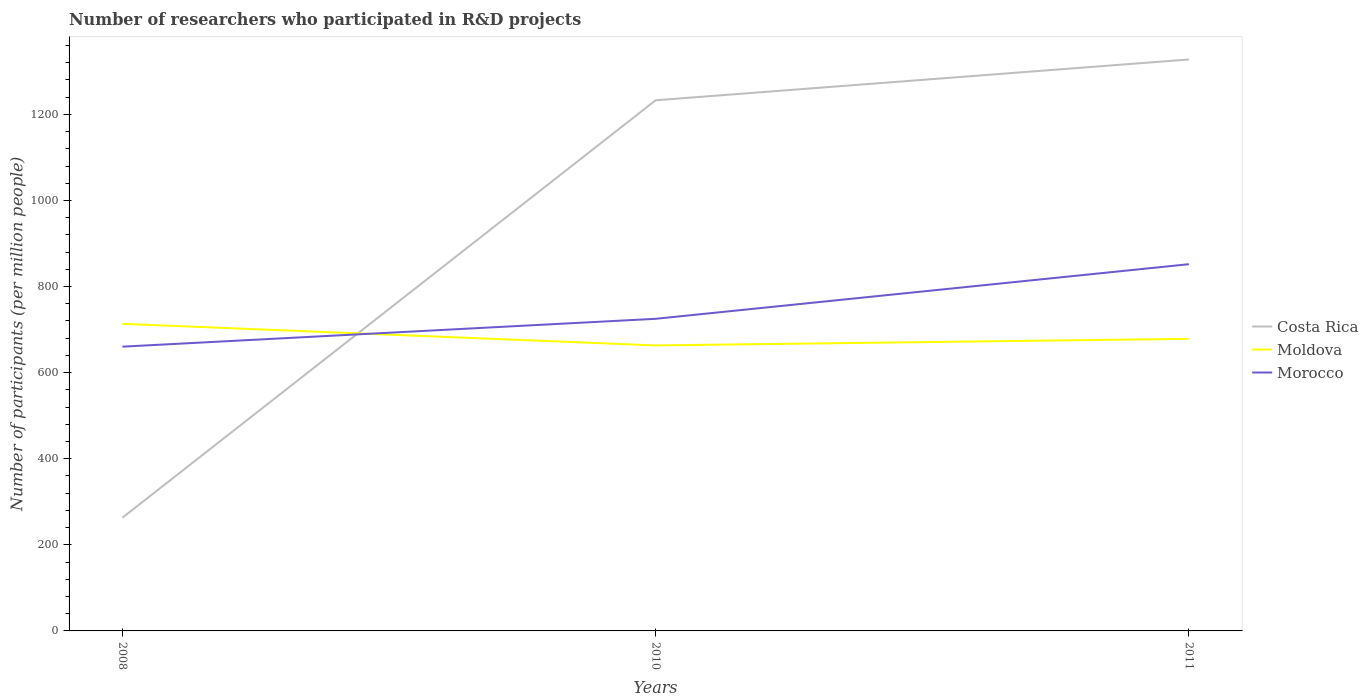How many different coloured lines are there?
Your answer should be compact. 3. Does the line corresponding to Costa Rica intersect with the line corresponding to Morocco?
Your answer should be compact. Yes. Across all years, what is the maximum number of researchers who participated in R&D projects in Morocco?
Your answer should be compact. 660.37. In which year was the number of researchers who participated in R&D projects in Morocco maximum?
Offer a terse response. 2008. What is the total number of researchers who participated in R&D projects in Moldova in the graph?
Keep it short and to the point. -15.31. What is the difference between the highest and the second highest number of researchers who participated in R&D projects in Moldova?
Offer a terse response. 50.18. What is the difference between the highest and the lowest number of researchers who participated in R&D projects in Morocco?
Make the answer very short. 1. How many lines are there?
Your answer should be compact. 3. How many years are there in the graph?
Your response must be concise. 3. Are the values on the major ticks of Y-axis written in scientific E-notation?
Keep it short and to the point. No. Does the graph contain grids?
Ensure brevity in your answer.  No. How are the legend labels stacked?
Keep it short and to the point. Vertical. What is the title of the graph?
Offer a very short reply. Number of researchers who participated in R&D projects. What is the label or title of the Y-axis?
Make the answer very short. Number of participants (per million people). What is the Number of participants (per million people) in Costa Rica in 2008?
Ensure brevity in your answer.  263.01. What is the Number of participants (per million people) of Moldova in 2008?
Give a very brief answer. 713.42. What is the Number of participants (per million people) of Morocco in 2008?
Offer a terse response. 660.37. What is the Number of participants (per million people) in Costa Rica in 2010?
Ensure brevity in your answer.  1232.71. What is the Number of participants (per million people) of Moldova in 2010?
Keep it short and to the point. 663.24. What is the Number of participants (per million people) in Morocco in 2010?
Your answer should be very brief. 725.06. What is the Number of participants (per million people) of Costa Rica in 2011?
Make the answer very short. 1327.47. What is the Number of participants (per million people) in Moldova in 2011?
Offer a terse response. 678.55. What is the Number of participants (per million people) of Morocco in 2011?
Offer a terse response. 851.9. Across all years, what is the maximum Number of participants (per million people) of Costa Rica?
Your answer should be compact. 1327.47. Across all years, what is the maximum Number of participants (per million people) in Moldova?
Offer a very short reply. 713.42. Across all years, what is the maximum Number of participants (per million people) in Morocco?
Your response must be concise. 851.9. Across all years, what is the minimum Number of participants (per million people) in Costa Rica?
Ensure brevity in your answer.  263.01. Across all years, what is the minimum Number of participants (per million people) of Moldova?
Offer a terse response. 663.24. Across all years, what is the minimum Number of participants (per million people) of Morocco?
Provide a short and direct response. 660.37. What is the total Number of participants (per million people) of Costa Rica in the graph?
Provide a short and direct response. 2823.19. What is the total Number of participants (per million people) in Moldova in the graph?
Your answer should be compact. 2055.21. What is the total Number of participants (per million people) of Morocco in the graph?
Ensure brevity in your answer.  2237.33. What is the difference between the Number of participants (per million people) in Costa Rica in 2008 and that in 2010?
Ensure brevity in your answer.  -969.7. What is the difference between the Number of participants (per million people) of Moldova in 2008 and that in 2010?
Offer a terse response. 50.18. What is the difference between the Number of participants (per million people) in Morocco in 2008 and that in 2010?
Your answer should be very brief. -64.69. What is the difference between the Number of participants (per million people) of Costa Rica in 2008 and that in 2011?
Your response must be concise. -1064.46. What is the difference between the Number of participants (per million people) in Moldova in 2008 and that in 2011?
Give a very brief answer. 34.87. What is the difference between the Number of participants (per million people) of Morocco in 2008 and that in 2011?
Provide a short and direct response. -191.53. What is the difference between the Number of participants (per million people) in Costa Rica in 2010 and that in 2011?
Your response must be concise. -94.76. What is the difference between the Number of participants (per million people) in Moldova in 2010 and that in 2011?
Your answer should be very brief. -15.31. What is the difference between the Number of participants (per million people) of Morocco in 2010 and that in 2011?
Offer a very short reply. -126.84. What is the difference between the Number of participants (per million people) in Costa Rica in 2008 and the Number of participants (per million people) in Moldova in 2010?
Provide a succinct answer. -400.23. What is the difference between the Number of participants (per million people) of Costa Rica in 2008 and the Number of participants (per million people) of Morocco in 2010?
Provide a succinct answer. -462.05. What is the difference between the Number of participants (per million people) of Moldova in 2008 and the Number of participants (per million people) of Morocco in 2010?
Offer a terse response. -11.64. What is the difference between the Number of participants (per million people) of Costa Rica in 2008 and the Number of participants (per million people) of Moldova in 2011?
Your answer should be compact. -415.54. What is the difference between the Number of participants (per million people) in Costa Rica in 2008 and the Number of participants (per million people) in Morocco in 2011?
Your answer should be very brief. -588.89. What is the difference between the Number of participants (per million people) of Moldova in 2008 and the Number of participants (per million people) of Morocco in 2011?
Your answer should be compact. -138.48. What is the difference between the Number of participants (per million people) of Costa Rica in 2010 and the Number of participants (per million people) of Moldova in 2011?
Provide a succinct answer. 554.16. What is the difference between the Number of participants (per million people) of Costa Rica in 2010 and the Number of participants (per million people) of Morocco in 2011?
Your answer should be compact. 380.81. What is the difference between the Number of participants (per million people) of Moldova in 2010 and the Number of participants (per million people) of Morocco in 2011?
Make the answer very short. -188.66. What is the average Number of participants (per million people) in Costa Rica per year?
Your answer should be very brief. 941.06. What is the average Number of participants (per million people) in Moldova per year?
Offer a very short reply. 685.07. What is the average Number of participants (per million people) of Morocco per year?
Offer a terse response. 745.78. In the year 2008, what is the difference between the Number of participants (per million people) of Costa Rica and Number of participants (per million people) of Moldova?
Your answer should be very brief. -450.41. In the year 2008, what is the difference between the Number of participants (per million people) in Costa Rica and Number of participants (per million people) in Morocco?
Your response must be concise. -397.36. In the year 2008, what is the difference between the Number of participants (per million people) in Moldova and Number of participants (per million people) in Morocco?
Provide a succinct answer. 53.05. In the year 2010, what is the difference between the Number of participants (per million people) of Costa Rica and Number of participants (per million people) of Moldova?
Ensure brevity in your answer.  569.47. In the year 2010, what is the difference between the Number of participants (per million people) in Costa Rica and Number of participants (per million people) in Morocco?
Provide a short and direct response. 507.65. In the year 2010, what is the difference between the Number of participants (per million people) of Moldova and Number of participants (per million people) of Morocco?
Ensure brevity in your answer.  -61.82. In the year 2011, what is the difference between the Number of participants (per million people) of Costa Rica and Number of participants (per million people) of Moldova?
Make the answer very short. 648.92. In the year 2011, what is the difference between the Number of participants (per million people) in Costa Rica and Number of participants (per million people) in Morocco?
Keep it short and to the point. 475.57. In the year 2011, what is the difference between the Number of participants (per million people) of Moldova and Number of participants (per million people) of Morocco?
Provide a succinct answer. -173.35. What is the ratio of the Number of participants (per million people) of Costa Rica in 2008 to that in 2010?
Give a very brief answer. 0.21. What is the ratio of the Number of participants (per million people) of Moldova in 2008 to that in 2010?
Your answer should be very brief. 1.08. What is the ratio of the Number of participants (per million people) in Morocco in 2008 to that in 2010?
Make the answer very short. 0.91. What is the ratio of the Number of participants (per million people) of Costa Rica in 2008 to that in 2011?
Give a very brief answer. 0.2. What is the ratio of the Number of participants (per million people) of Moldova in 2008 to that in 2011?
Provide a short and direct response. 1.05. What is the ratio of the Number of participants (per million people) of Morocco in 2008 to that in 2011?
Ensure brevity in your answer.  0.78. What is the ratio of the Number of participants (per million people) of Moldova in 2010 to that in 2011?
Provide a succinct answer. 0.98. What is the ratio of the Number of participants (per million people) of Morocco in 2010 to that in 2011?
Give a very brief answer. 0.85. What is the difference between the highest and the second highest Number of participants (per million people) in Costa Rica?
Ensure brevity in your answer.  94.76. What is the difference between the highest and the second highest Number of participants (per million people) of Moldova?
Provide a succinct answer. 34.87. What is the difference between the highest and the second highest Number of participants (per million people) in Morocco?
Give a very brief answer. 126.84. What is the difference between the highest and the lowest Number of participants (per million people) of Costa Rica?
Your answer should be very brief. 1064.46. What is the difference between the highest and the lowest Number of participants (per million people) in Moldova?
Make the answer very short. 50.18. What is the difference between the highest and the lowest Number of participants (per million people) in Morocco?
Keep it short and to the point. 191.53. 